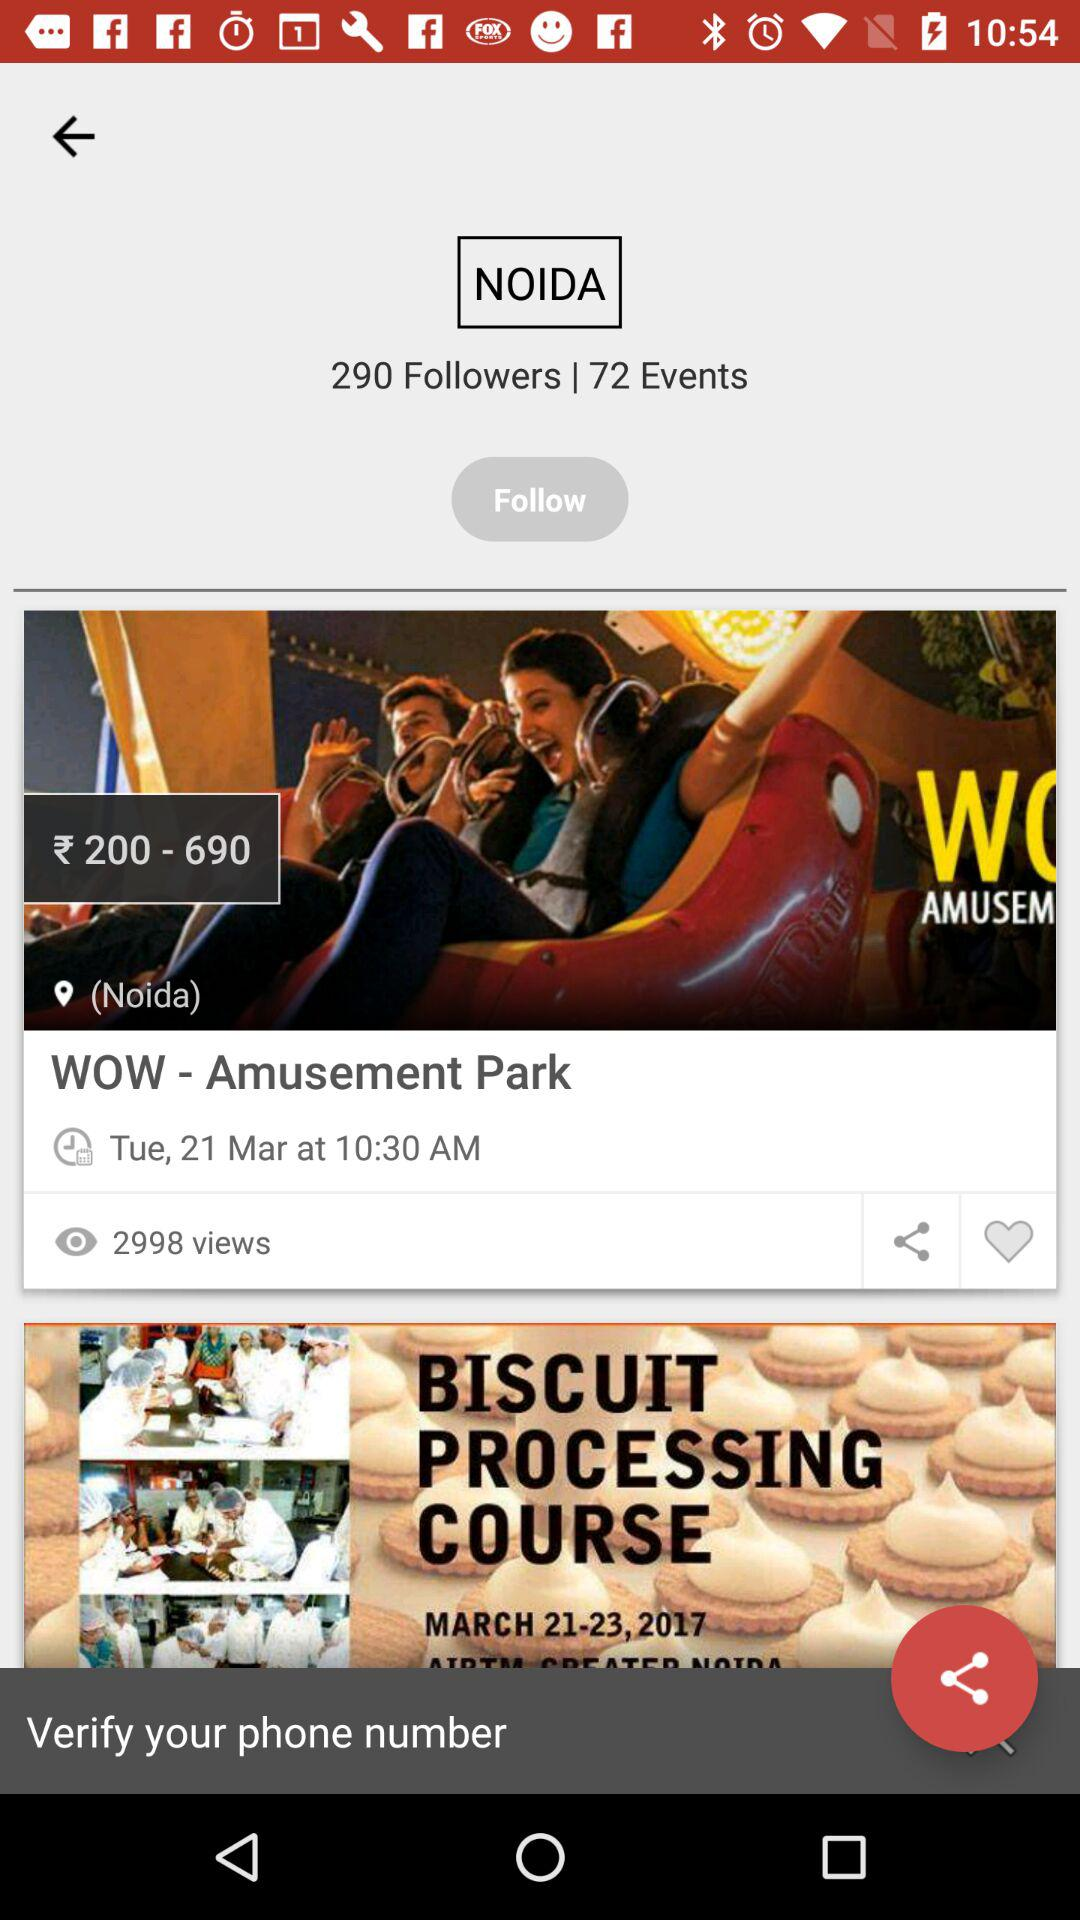How many events are there? There are 72 events. 